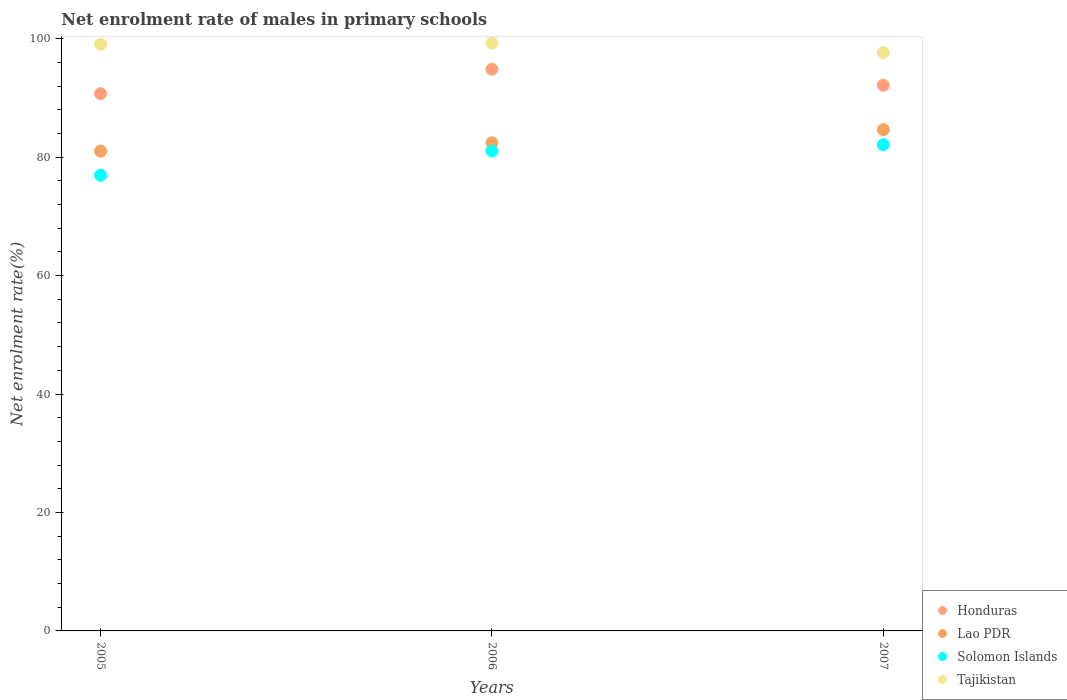What is the net enrolment rate of males in primary schools in Solomon Islands in 2005?
Keep it short and to the point. 76.95. Across all years, what is the maximum net enrolment rate of males in primary schools in Tajikistan?
Ensure brevity in your answer.  99.25. Across all years, what is the minimum net enrolment rate of males in primary schools in Tajikistan?
Your answer should be compact. 97.64. In which year was the net enrolment rate of males in primary schools in Solomon Islands maximum?
Your response must be concise. 2007. What is the total net enrolment rate of males in primary schools in Tajikistan in the graph?
Your answer should be compact. 295.94. What is the difference between the net enrolment rate of males in primary schools in Solomon Islands in 2005 and that in 2007?
Provide a short and direct response. -5.14. What is the difference between the net enrolment rate of males in primary schools in Solomon Islands in 2006 and the net enrolment rate of males in primary schools in Lao PDR in 2007?
Ensure brevity in your answer.  -3.61. What is the average net enrolment rate of males in primary schools in Solomon Islands per year?
Ensure brevity in your answer.  80.03. In the year 2005, what is the difference between the net enrolment rate of males in primary schools in Lao PDR and net enrolment rate of males in primary schools in Honduras?
Offer a terse response. -9.71. In how many years, is the net enrolment rate of males in primary schools in Solomon Islands greater than 44 %?
Offer a terse response. 3. What is the ratio of the net enrolment rate of males in primary schools in Lao PDR in 2005 to that in 2007?
Provide a short and direct response. 0.96. Is the difference between the net enrolment rate of males in primary schools in Lao PDR in 2005 and 2007 greater than the difference between the net enrolment rate of males in primary schools in Honduras in 2005 and 2007?
Ensure brevity in your answer.  No. What is the difference between the highest and the second highest net enrolment rate of males in primary schools in Honduras?
Provide a succinct answer. 2.71. What is the difference between the highest and the lowest net enrolment rate of males in primary schools in Honduras?
Ensure brevity in your answer.  4.12. In how many years, is the net enrolment rate of males in primary schools in Lao PDR greater than the average net enrolment rate of males in primary schools in Lao PDR taken over all years?
Offer a terse response. 1. Is it the case that in every year, the sum of the net enrolment rate of males in primary schools in Tajikistan and net enrolment rate of males in primary schools in Honduras  is greater than the sum of net enrolment rate of males in primary schools in Lao PDR and net enrolment rate of males in primary schools in Solomon Islands?
Your answer should be compact. Yes. Is it the case that in every year, the sum of the net enrolment rate of males in primary schools in Solomon Islands and net enrolment rate of males in primary schools in Lao PDR  is greater than the net enrolment rate of males in primary schools in Honduras?
Your answer should be compact. Yes. How many dotlines are there?
Offer a very short reply. 4. What is the difference between two consecutive major ticks on the Y-axis?
Ensure brevity in your answer.  20. Where does the legend appear in the graph?
Your answer should be compact. Bottom right. How many legend labels are there?
Ensure brevity in your answer.  4. How are the legend labels stacked?
Offer a terse response. Vertical. What is the title of the graph?
Your response must be concise. Net enrolment rate of males in primary schools. Does "Suriname" appear as one of the legend labels in the graph?
Ensure brevity in your answer.  No. What is the label or title of the X-axis?
Provide a succinct answer. Years. What is the label or title of the Y-axis?
Give a very brief answer. Net enrolment rate(%). What is the Net enrolment rate(%) of Honduras in 2005?
Provide a succinct answer. 90.73. What is the Net enrolment rate(%) of Lao PDR in 2005?
Your answer should be compact. 81.02. What is the Net enrolment rate(%) in Solomon Islands in 2005?
Provide a succinct answer. 76.95. What is the Net enrolment rate(%) of Tajikistan in 2005?
Keep it short and to the point. 99.05. What is the Net enrolment rate(%) of Honduras in 2006?
Your response must be concise. 94.85. What is the Net enrolment rate(%) of Lao PDR in 2006?
Keep it short and to the point. 82.43. What is the Net enrolment rate(%) of Solomon Islands in 2006?
Offer a terse response. 81.04. What is the Net enrolment rate(%) of Tajikistan in 2006?
Your answer should be very brief. 99.25. What is the Net enrolment rate(%) of Honduras in 2007?
Offer a terse response. 92.14. What is the Net enrolment rate(%) in Lao PDR in 2007?
Give a very brief answer. 84.66. What is the Net enrolment rate(%) in Solomon Islands in 2007?
Your answer should be compact. 82.1. What is the Net enrolment rate(%) in Tajikistan in 2007?
Make the answer very short. 97.64. Across all years, what is the maximum Net enrolment rate(%) of Honduras?
Give a very brief answer. 94.85. Across all years, what is the maximum Net enrolment rate(%) in Lao PDR?
Your answer should be very brief. 84.66. Across all years, what is the maximum Net enrolment rate(%) of Solomon Islands?
Give a very brief answer. 82.1. Across all years, what is the maximum Net enrolment rate(%) in Tajikistan?
Ensure brevity in your answer.  99.25. Across all years, what is the minimum Net enrolment rate(%) in Honduras?
Your response must be concise. 90.73. Across all years, what is the minimum Net enrolment rate(%) of Lao PDR?
Your answer should be very brief. 81.02. Across all years, what is the minimum Net enrolment rate(%) in Solomon Islands?
Ensure brevity in your answer.  76.95. Across all years, what is the minimum Net enrolment rate(%) of Tajikistan?
Your answer should be compact. 97.64. What is the total Net enrolment rate(%) of Honduras in the graph?
Provide a short and direct response. 277.72. What is the total Net enrolment rate(%) of Lao PDR in the graph?
Provide a succinct answer. 248.11. What is the total Net enrolment rate(%) of Solomon Islands in the graph?
Provide a short and direct response. 240.09. What is the total Net enrolment rate(%) of Tajikistan in the graph?
Keep it short and to the point. 295.94. What is the difference between the Net enrolment rate(%) of Honduras in 2005 and that in 2006?
Offer a terse response. -4.12. What is the difference between the Net enrolment rate(%) of Lao PDR in 2005 and that in 2006?
Offer a very short reply. -1.41. What is the difference between the Net enrolment rate(%) of Solomon Islands in 2005 and that in 2006?
Provide a short and direct response. -4.09. What is the difference between the Net enrolment rate(%) in Tajikistan in 2005 and that in 2006?
Your response must be concise. -0.19. What is the difference between the Net enrolment rate(%) in Honduras in 2005 and that in 2007?
Keep it short and to the point. -1.41. What is the difference between the Net enrolment rate(%) of Lao PDR in 2005 and that in 2007?
Keep it short and to the point. -3.64. What is the difference between the Net enrolment rate(%) of Solomon Islands in 2005 and that in 2007?
Your response must be concise. -5.14. What is the difference between the Net enrolment rate(%) of Tajikistan in 2005 and that in 2007?
Your answer should be very brief. 1.41. What is the difference between the Net enrolment rate(%) in Honduras in 2006 and that in 2007?
Offer a terse response. 2.71. What is the difference between the Net enrolment rate(%) of Lao PDR in 2006 and that in 2007?
Your response must be concise. -2.23. What is the difference between the Net enrolment rate(%) in Solomon Islands in 2006 and that in 2007?
Make the answer very short. -1.05. What is the difference between the Net enrolment rate(%) in Tajikistan in 2006 and that in 2007?
Your answer should be compact. 1.61. What is the difference between the Net enrolment rate(%) in Honduras in 2005 and the Net enrolment rate(%) in Lao PDR in 2006?
Offer a very short reply. 8.3. What is the difference between the Net enrolment rate(%) of Honduras in 2005 and the Net enrolment rate(%) of Solomon Islands in 2006?
Your response must be concise. 9.69. What is the difference between the Net enrolment rate(%) in Honduras in 2005 and the Net enrolment rate(%) in Tajikistan in 2006?
Make the answer very short. -8.52. What is the difference between the Net enrolment rate(%) in Lao PDR in 2005 and the Net enrolment rate(%) in Solomon Islands in 2006?
Your answer should be very brief. -0.02. What is the difference between the Net enrolment rate(%) in Lao PDR in 2005 and the Net enrolment rate(%) in Tajikistan in 2006?
Offer a very short reply. -18.23. What is the difference between the Net enrolment rate(%) of Solomon Islands in 2005 and the Net enrolment rate(%) of Tajikistan in 2006?
Give a very brief answer. -22.3. What is the difference between the Net enrolment rate(%) in Honduras in 2005 and the Net enrolment rate(%) in Lao PDR in 2007?
Offer a very short reply. 6.07. What is the difference between the Net enrolment rate(%) of Honduras in 2005 and the Net enrolment rate(%) of Solomon Islands in 2007?
Keep it short and to the point. 8.63. What is the difference between the Net enrolment rate(%) of Honduras in 2005 and the Net enrolment rate(%) of Tajikistan in 2007?
Ensure brevity in your answer.  -6.91. What is the difference between the Net enrolment rate(%) in Lao PDR in 2005 and the Net enrolment rate(%) in Solomon Islands in 2007?
Provide a succinct answer. -1.07. What is the difference between the Net enrolment rate(%) in Lao PDR in 2005 and the Net enrolment rate(%) in Tajikistan in 2007?
Your answer should be very brief. -16.62. What is the difference between the Net enrolment rate(%) of Solomon Islands in 2005 and the Net enrolment rate(%) of Tajikistan in 2007?
Provide a succinct answer. -20.69. What is the difference between the Net enrolment rate(%) in Honduras in 2006 and the Net enrolment rate(%) in Lao PDR in 2007?
Your response must be concise. 10.2. What is the difference between the Net enrolment rate(%) of Honduras in 2006 and the Net enrolment rate(%) of Solomon Islands in 2007?
Make the answer very short. 12.76. What is the difference between the Net enrolment rate(%) in Honduras in 2006 and the Net enrolment rate(%) in Tajikistan in 2007?
Your answer should be very brief. -2.79. What is the difference between the Net enrolment rate(%) in Lao PDR in 2006 and the Net enrolment rate(%) in Solomon Islands in 2007?
Offer a terse response. 0.33. What is the difference between the Net enrolment rate(%) in Lao PDR in 2006 and the Net enrolment rate(%) in Tajikistan in 2007?
Offer a very short reply. -15.21. What is the difference between the Net enrolment rate(%) in Solomon Islands in 2006 and the Net enrolment rate(%) in Tajikistan in 2007?
Your response must be concise. -16.6. What is the average Net enrolment rate(%) of Honduras per year?
Ensure brevity in your answer.  92.57. What is the average Net enrolment rate(%) of Lao PDR per year?
Provide a short and direct response. 82.7. What is the average Net enrolment rate(%) in Solomon Islands per year?
Your response must be concise. 80.03. What is the average Net enrolment rate(%) in Tajikistan per year?
Make the answer very short. 98.65. In the year 2005, what is the difference between the Net enrolment rate(%) of Honduras and Net enrolment rate(%) of Lao PDR?
Keep it short and to the point. 9.71. In the year 2005, what is the difference between the Net enrolment rate(%) in Honduras and Net enrolment rate(%) in Solomon Islands?
Your answer should be compact. 13.78. In the year 2005, what is the difference between the Net enrolment rate(%) in Honduras and Net enrolment rate(%) in Tajikistan?
Your answer should be very brief. -8.32. In the year 2005, what is the difference between the Net enrolment rate(%) in Lao PDR and Net enrolment rate(%) in Solomon Islands?
Your response must be concise. 4.07. In the year 2005, what is the difference between the Net enrolment rate(%) of Lao PDR and Net enrolment rate(%) of Tajikistan?
Offer a very short reply. -18.03. In the year 2005, what is the difference between the Net enrolment rate(%) in Solomon Islands and Net enrolment rate(%) in Tajikistan?
Offer a terse response. -22.1. In the year 2006, what is the difference between the Net enrolment rate(%) in Honduras and Net enrolment rate(%) in Lao PDR?
Ensure brevity in your answer.  12.42. In the year 2006, what is the difference between the Net enrolment rate(%) in Honduras and Net enrolment rate(%) in Solomon Islands?
Your answer should be very brief. 13.81. In the year 2006, what is the difference between the Net enrolment rate(%) in Honduras and Net enrolment rate(%) in Tajikistan?
Keep it short and to the point. -4.4. In the year 2006, what is the difference between the Net enrolment rate(%) in Lao PDR and Net enrolment rate(%) in Solomon Islands?
Your response must be concise. 1.39. In the year 2006, what is the difference between the Net enrolment rate(%) in Lao PDR and Net enrolment rate(%) in Tajikistan?
Your answer should be compact. -16.82. In the year 2006, what is the difference between the Net enrolment rate(%) in Solomon Islands and Net enrolment rate(%) in Tajikistan?
Your answer should be compact. -18.21. In the year 2007, what is the difference between the Net enrolment rate(%) in Honduras and Net enrolment rate(%) in Lao PDR?
Your answer should be compact. 7.48. In the year 2007, what is the difference between the Net enrolment rate(%) of Honduras and Net enrolment rate(%) of Solomon Islands?
Give a very brief answer. 10.05. In the year 2007, what is the difference between the Net enrolment rate(%) of Honduras and Net enrolment rate(%) of Tajikistan?
Offer a very short reply. -5.5. In the year 2007, what is the difference between the Net enrolment rate(%) of Lao PDR and Net enrolment rate(%) of Solomon Islands?
Provide a succinct answer. 2.56. In the year 2007, what is the difference between the Net enrolment rate(%) of Lao PDR and Net enrolment rate(%) of Tajikistan?
Keep it short and to the point. -12.98. In the year 2007, what is the difference between the Net enrolment rate(%) of Solomon Islands and Net enrolment rate(%) of Tajikistan?
Provide a succinct answer. -15.55. What is the ratio of the Net enrolment rate(%) of Honduras in 2005 to that in 2006?
Your answer should be compact. 0.96. What is the ratio of the Net enrolment rate(%) in Lao PDR in 2005 to that in 2006?
Your answer should be compact. 0.98. What is the ratio of the Net enrolment rate(%) of Solomon Islands in 2005 to that in 2006?
Your response must be concise. 0.95. What is the ratio of the Net enrolment rate(%) in Tajikistan in 2005 to that in 2006?
Provide a short and direct response. 1. What is the ratio of the Net enrolment rate(%) in Honduras in 2005 to that in 2007?
Your answer should be very brief. 0.98. What is the ratio of the Net enrolment rate(%) in Lao PDR in 2005 to that in 2007?
Your answer should be very brief. 0.96. What is the ratio of the Net enrolment rate(%) in Solomon Islands in 2005 to that in 2007?
Your response must be concise. 0.94. What is the ratio of the Net enrolment rate(%) in Tajikistan in 2005 to that in 2007?
Your answer should be compact. 1.01. What is the ratio of the Net enrolment rate(%) of Honduras in 2006 to that in 2007?
Make the answer very short. 1.03. What is the ratio of the Net enrolment rate(%) in Lao PDR in 2006 to that in 2007?
Provide a short and direct response. 0.97. What is the ratio of the Net enrolment rate(%) of Solomon Islands in 2006 to that in 2007?
Your response must be concise. 0.99. What is the ratio of the Net enrolment rate(%) of Tajikistan in 2006 to that in 2007?
Give a very brief answer. 1.02. What is the difference between the highest and the second highest Net enrolment rate(%) in Honduras?
Provide a short and direct response. 2.71. What is the difference between the highest and the second highest Net enrolment rate(%) in Lao PDR?
Ensure brevity in your answer.  2.23. What is the difference between the highest and the second highest Net enrolment rate(%) of Solomon Islands?
Keep it short and to the point. 1.05. What is the difference between the highest and the second highest Net enrolment rate(%) of Tajikistan?
Provide a succinct answer. 0.19. What is the difference between the highest and the lowest Net enrolment rate(%) of Honduras?
Offer a very short reply. 4.12. What is the difference between the highest and the lowest Net enrolment rate(%) of Lao PDR?
Your answer should be very brief. 3.64. What is the difference between the highest and the lowest Net enrolment rate(%) in Solomon Islands?
Provide a short and direct response. 5.14. What is the difference between the highest and the lowest Net enrolment rate(%) in Tajikistan?
Ensure brevity in your answer.  1.61. 